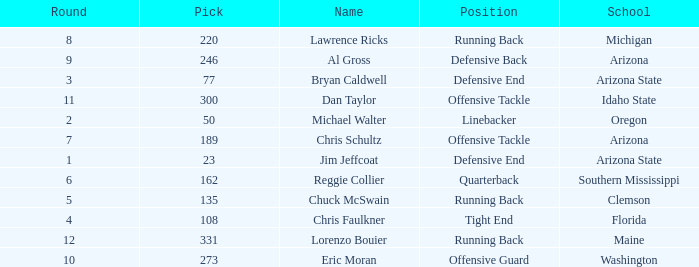What is the largest pick in round 8? 220.0. 